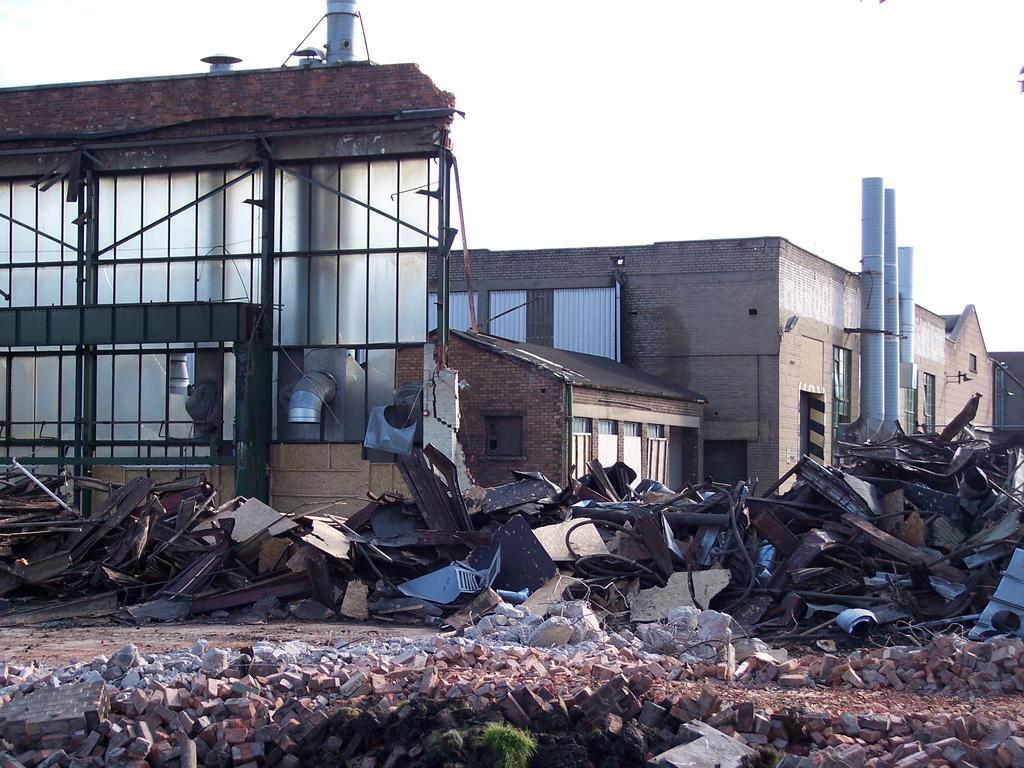Describe this image in one or two sentences. In this image I can see few bricks on the ground, few damaged benches and items on the ground, a destructed building, few other buildings, few huge pipes to the building and in the background I can see the sky. 